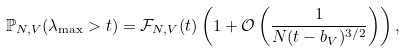<formula> <loc_0><loc_0><loc_500><loc_500>\mathbb { P } _ { N , V } ( \lambda _ { \max } > t ) = \mathcal { F } _ { N , V } ( t ) \left ( 1 + \mathcal { O } \left ( \frac { 1 } { N ( t - b _ { V } ) ^ { 3 / 2 } } \right ) \right ) ,</formula> 